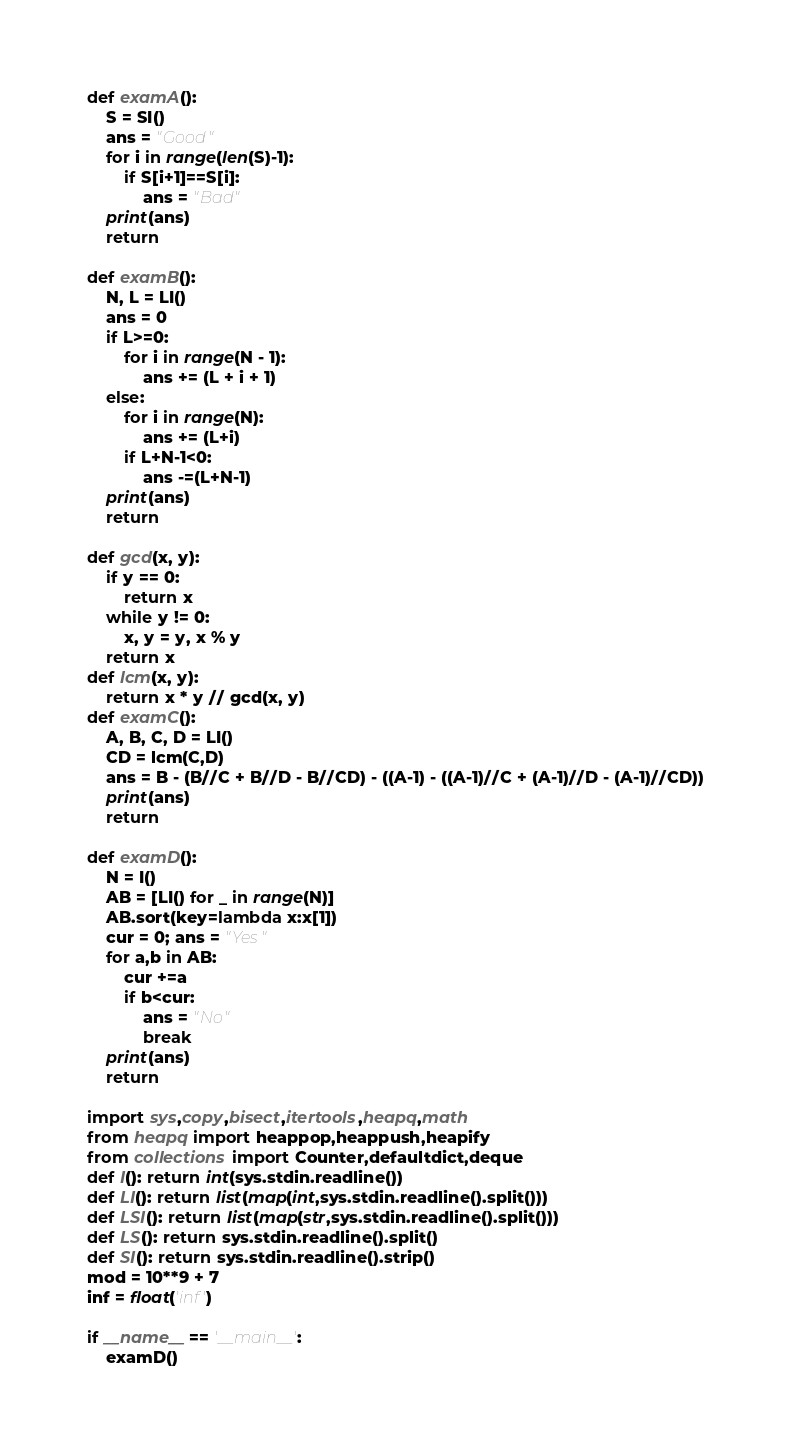Convert code to text. <code><loc_0><loc_0><loc_500><loc_500><_Python_>def examA():
    S = SI()
    ans = "Good"
    for i in range(len(S)-1):
        if S[i+1]==S[i]:
            ans = "Bad"
    print(ans)
    return

def examB():
    N, L = LI()
    ans = 0
    if L>=0:
        for i in range(N - 1):
            ans += (L + i + 1)
    else:
        for i in range(N):
            ans += (L+i)
        if L+N-1<0:
            ans -=(L+N-1)
    print(ans)
    return

def gcd(x, y):
    if y == 0:
        return x
    while y != 0:
        x, y = y, x % y
    return x
def lcm(x, y):
    return x * y // gcd(x, y)
def examC():
    A, B, C, D = LI()
    CD = lcm(C,D)
    ans = B - (B//C + B//D - B//CD) - ((A-1) - ((A-1)//C + (A-1)//D - (A-1)//CD))
    print(ans)
    return

def examD():
    N = I()
    AB = [LI() for _ in range(N)]
    AB.sort(key=lambda x:x[1])
    cur = 0; ans = "Yes"
    for a,b in AB:
        cur +=a
        if b<cur:
            ans = "No"
            break
    print(ans)
    return

import sys,copy,bisect,itertools,heapq,math
from heapq import heappop,heappush,heapify
from collections import Counter,defaultdict,deque
def I(): return int(sys.stdin.readline())
def LI(): return list(map(int,sys.stdin.readline().split()))
def LSI(): return list(map(str,sys.stdin.readline().split()))
def LS(): return sys.stdin.readline().split()
def SI(): return sys.stdin.readline().strip()
mod = 10**9 + 7
inf = float('inf')

if __name__ == '__main__':
    examD()
</code> 